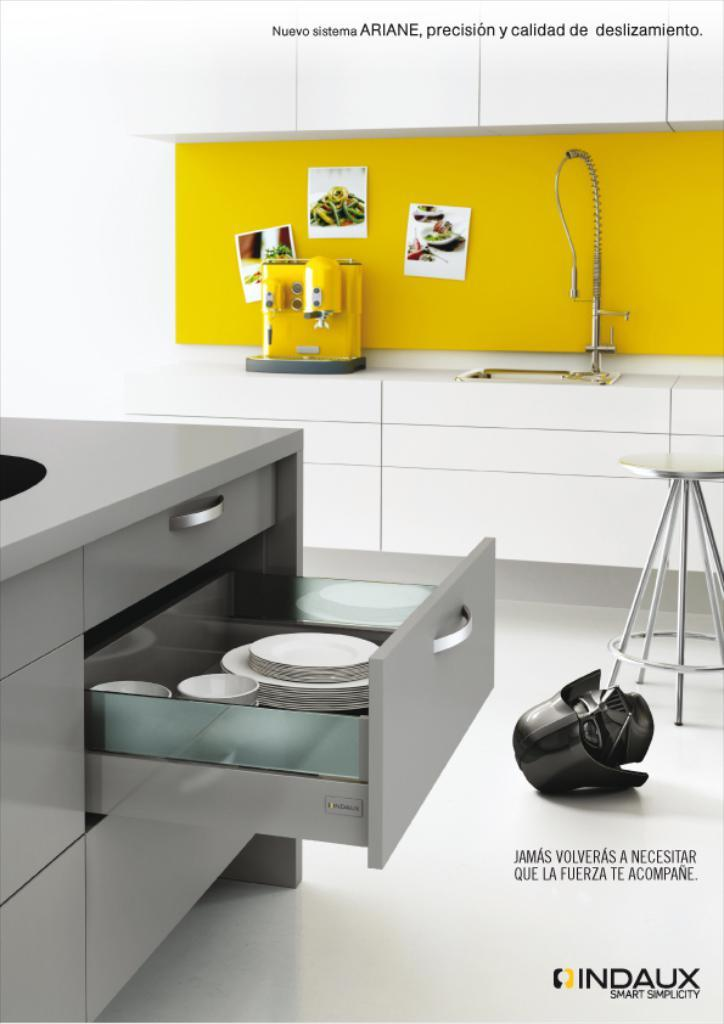<image>
Give a short and clear explanation of the subsequent image. An advertisement for Indaux simplicity home furnishings shows a convenient kitchen setup. 